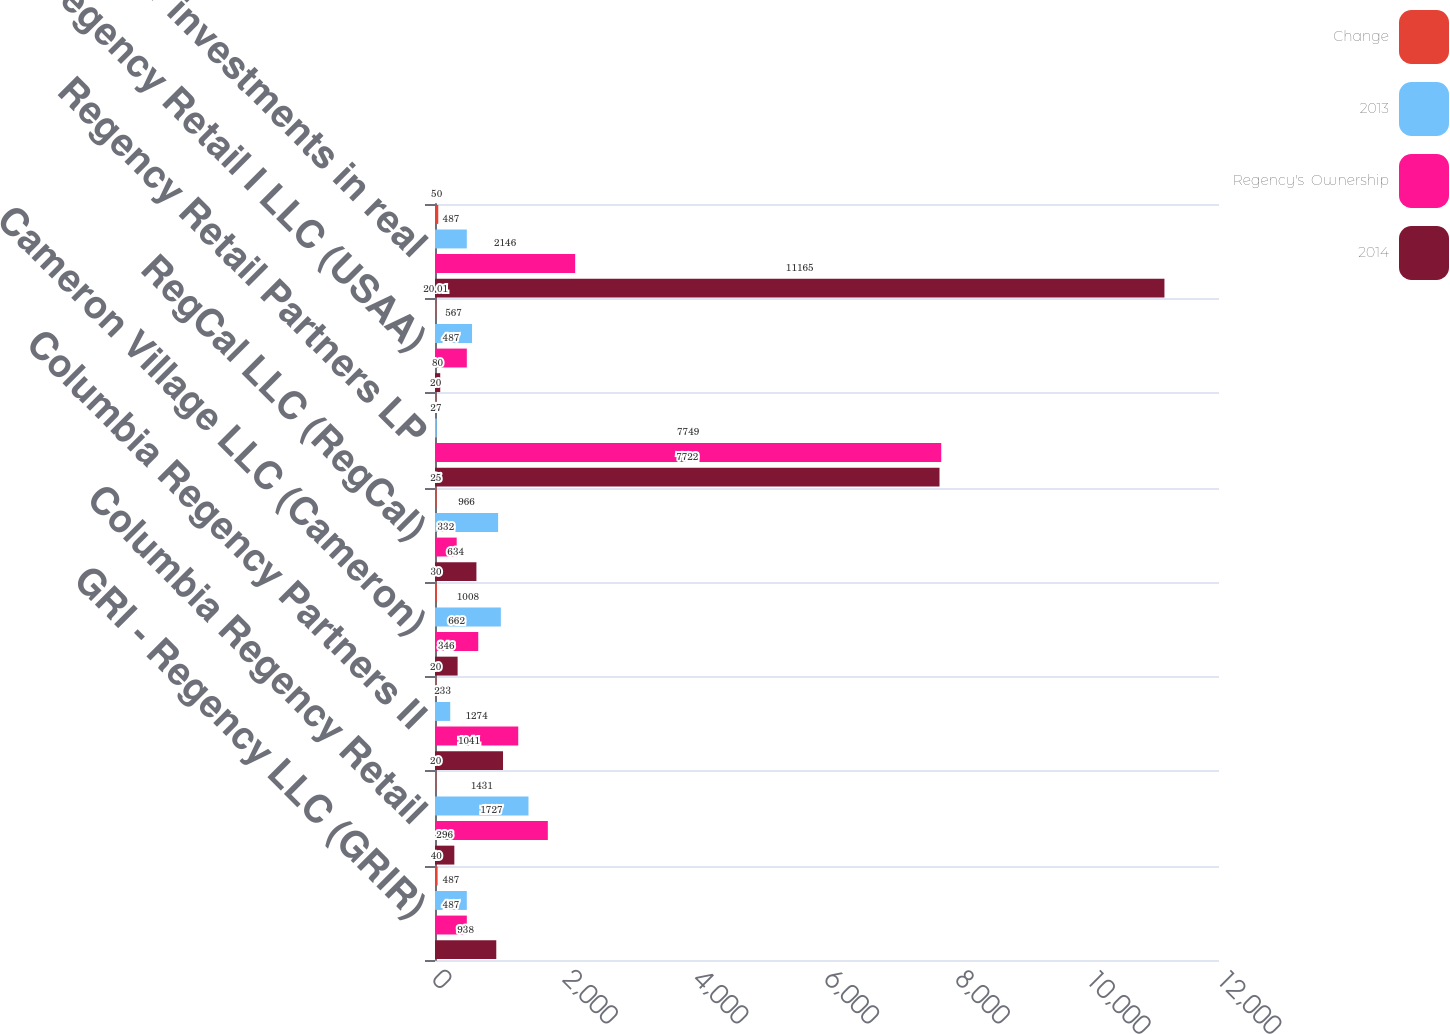Convert chart to OTSL. <chart><loc_0><loc_0><loc_500><loc_500><stacked_bar_chart><ecel><fcel>GRI - Regency LLC (GRIR)<fcel>Columbia Regency Retail<fcel>Columbia Regency Partners II<fcel>Cameron Village LLC (Cameron)<fcel>RegCal LLC (RegCal)<fcel>Regency Retail Partners LP<fcel>US Regency Retail I LLC (USAA)<fcel>Other investments in real<nl><fcel>Change<fcel>40<fcel>20<fcel>20<fcel>30<fcel>25<fcel>20<fcel>20.01<fcel>50<nl><fcel>2013<fcel>487<fcel>1431<fcel>233<fcel>1008<fcel>966<fcel>27<fcel>567<fcel>487<nl><fcel>Regency's  Ownership<fcel>487<fcel>1727<fcel>1274<fcel>662<fcel>332<fcel>7749<fcel>487<fcel>2146<nl><fcel>2014<fcel>938<fcel>296<fcel>1041<fcel>346<fcel>634<fcel>7722<fcel>80<fcel>11165<nl></chart> 